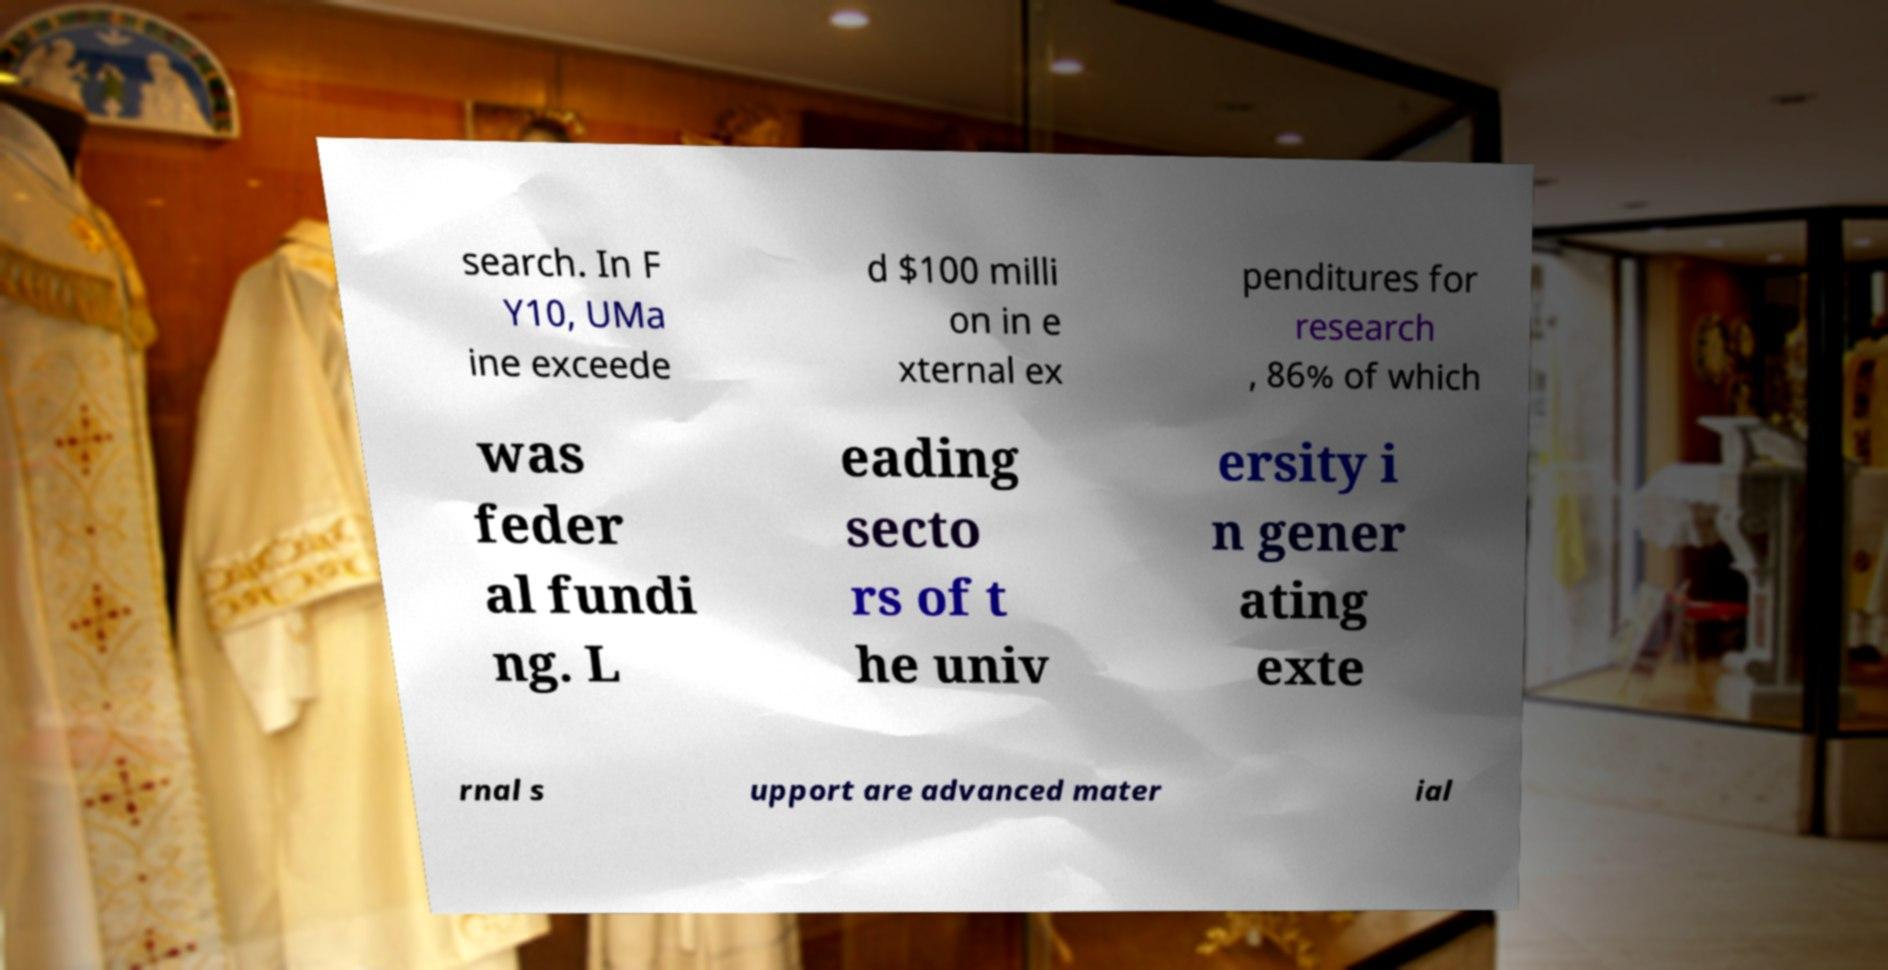Could you extract and type out the text from this image? search. In F Y10, UMa ine exceede d $100 milli on in e xternal ex penditures for research , 86% of which was feder al fundi ng. L eading secto rs of t he univ ersity i n gener ating exte rnal s upport are advanced mater ial 